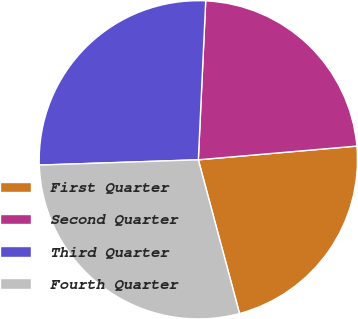<chart> <loc_0><loc_0><loc_500><loc_500><pie_chart><fcel>First Quarter<fcel>Second Quarter<fcel>Third Quarter<fcel>Fourth Quarter<nl><fcel>22.21%<fcel>22.89%<fcel>26.27%<fcel>28.64%<nl></chart> 